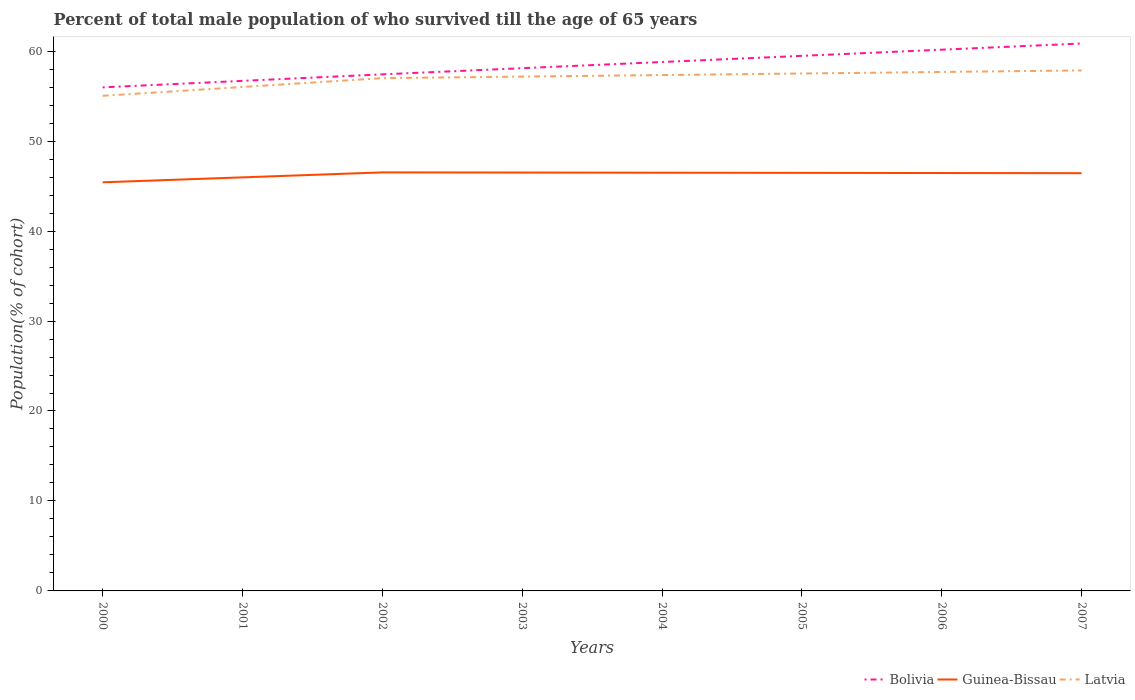How many different coloured lines are there?
Provide a short and direct response. 3. Across all years, what is the maximum percentage of total male population who survived till the age of 65 years in Bolivia?
Offer a very short reply. 55.97. In which year was the percentage of total male population who survived till the age of 65 years in Bolivia maximum?
Give a very brief answer. 2000. What is the total percentage of total male population who survived till the age of 65 years in Bolivia in the graph?
Offer a terse response. -3.5. What is the difference between the highest and the second highest percentage of total male population who survived till the age of 65 years in Bolivia?
Give a very brief answer. 4.87. What is the difference between the highest and the lowest percentage of total male population who survived till the age of 65 years in Bolivia?
Provide a short and direct response. 4. Is the percentage of total male population who survived till the age of 65 years in Latvia strictly greater than the percentage of total male population who survived till the age of 65 years in Bolivia over the years?
Keep it short and to the point. Yes. How many lines are there?
Provide a succinct answer. 3. Does the graph contain grids?
Give a very brief answer. No. What is the title of the graph?
Ensure brevity in your answer.  Percent of total male population of who survived till the age of 65 years. What is the label or title of the X-axis?
Make the answer very short. Years. What is the label or title of the Y-axis?
Make the answer very short. Population(% of cohort). What is the Population(% of cohort) in Bolivia in 2000?
Provide a short and direct response. 55.97. What is the Population(% of cohort) of Guinea-Bissau in 2000?
Give a very brief answer. 45.42. What is the Population(% of cohort) in Latvia in 2000?
Your answer should be compact. 55.03. What is the Population(% of cohort) in Bolivia in 2001?
Provide a succinct answer. 56.7. What is the Population(% of cohort) of Guinea-Bissau in 2001?
Your answer should be compact. 45.97. What is the Population(% of cohort) of Latvia in 2001?
Ensure brevity in your answer.  56.02. What is the Population(% of cohort) in Bolivia in 2002?
Provide a succinct answer. 57.42. What is the Population(% of cohort) of Guinea-Bissau in 2002?
Your response must be concise. 46.52. What is the Population(% of cohort) in Latvia in 2002?
Ensure brevity in your answer.  57. What is the Population(% of cohort) of Bolivia in 2003?
Keep it short and to the point. 58.1. What is the Population(% of cohort) of Guinea-Bissau in 2003?
Your answer should be very brief. 46.5. What is the Population(% of cohort) of Latvia in 2003?
Provide a succinct answer. 57.17. What is the Population(% of cohort) of Bolivia in 2004?
Keep it short and to the point. 58.79. What is the Population(% of cohort) of Guinea-Bissau in 2004?
Provide a succinct answer. 46.49. What is the Population(% of cohort) of Latvia in 2004?
Give a very brief answer. 57.34. What is the Population(% of cohort) of Bolivia in 2005?
Make the answer very short. 59.48. What is the Population(% of cohort) of Guinea-Bissau in 2005?
Give a very brief answer. 46.47. What is the Population(% of cohort) of Latvia in 2005?
Your response must be concise. 57.51. What is the Population(% of cohort) of Bolivia in 2006?
Your response must be concise. 60.16. What is the Population(% of cohort) in Guinea-Bissau in 2006?
Provide a short and direct response. 46.45. What is the Population(% of cohort) of Latvia in 2006?
Provide a short and direct response. 57.69. What is the Population(% of cohort) of Bolivia in 2007?
Give a very brief answer. 60.85. What is the Population(% of cohort) in Guinea-Bissau in 2007?
Ensure brevity in your answer.  46.43. What is the Population(% of cohort) of Latvia in 2007?
Make the answer very short. 57.86. Across all years, what is the maximum Population(% of cohort) of Bolivia?
Give a very brief answer. 60.85. Across all years, what is the maximum Population(% of cohort) in Guinea-Bissau?
Give a very brief answer. 46.52. Across all years, what is the maximum Population(% of cohort) of Latvia?
Offer a very short reply. 57.86. Across all years, what is the minimum Population(% of cohort) in Bolivia?
Offer a very short reply. 55.97. Across all years, what is the minimum Population(% of cohort) in Guinea-Bissau?
Ensure brevity in your answer.  45.42. Across all years, what is the minimum Population(% of cohort) in Latvia?
Offer a very short reply. 55.03. What is the total Population(% of cohort) in Bolivia in the graph?
Keep it short and to the point. 467.47. What is the total Population(% of cohort) of Guinea-Bissau in the graph?
Keep it short and to the point. 370.26. What is the total Population(% of cohort) of Latvia in the graph?
Keep it short and to the point. 455.62. What is the difference between the Population(% of cohort) of Bolivia in 2000 and that in 2001?
Offer a terse response. -0.72. What is the difference between the Population(% of cohort) of Guinea-Bissau in 2000 and that in 2001?
Your answer should be compact. -0.55. What is the difference between the Population(% of cohort) of Latvia in 2000 and that in 2001?
Give a very brief answer. -0.98. What is the difference between the Population(% of cohort) in Bolivia in 2000 and that in 2002?
Ensure brevity in your answer.  -1.45. What is the difference between the Population(% of cohort) in Guinea-Bissau in 2000 and that in 2002?
Your answer should be very brief. -1.1. What is the difference between the Population(% of cohort) of Latvia in 2000 and that in 2002?
Offer a very short reply. -1.96. What is the difference between the Population(% of cohort) in Bolivia in 2000 and that in 2003?
Offer a very short reply. -2.13. What is the difference between the Population(% of cohort) in Guinea-Bissau in 2000 and that in 2003?
Your response must be concise. -1.09. What is the difference between the Population(% of cohort) of Latvia in 2000 and that in 2003?
Ensure brevity in your answer.  -2.13. What is the difference between the Population(% of cohort) in Bolivia in 2000 and that in 2004?
Make the answer very short. -2.82. What is the difference between the Population(% of cohort) of Guinea-Bissau in 2000 and that in 2004?
Your answer should be very brief. -1.07. What is the difference between the Population(% of cohort) in Latvia in 2000 and that in 2004?
Offer a terse response. -2.31. What is the difference between the Population(% of cohort) in Bolivia in 2000 and that in 2005?
Offer a very short reply. -3.5. What is the difference between the Population(% of cohort) in Guinea-Bissau in 2000 and that in 2005?
Your response must be concise. -1.05. What is the difference between the Population(% of cohort) in Latvia in 2000 and that in 2005?
Offer a terse response. -2.48. What is the difference between the Population(% of cohort) of Bolivia in 2000 and that in 2006?
Offer a terse response. -4.19. What is the difference between the Population(% of cohort) in Guinea-Bissau in 2000 and that in 2006?
Your answer should be compact. -1.03. What is the difference between the Population(% of cohort) of Latvia in 2000 and that in 2006?
Provide a succinct answer. -2.65. What is the difference between the Population(% of cohort) of Bolivia in 2000 and that in 2007?
Your answer should be very brief. -4.87. What is the difference between the Population(% of cohort) in Guinea-Bissau in 2000 and that in 2007?
Your response must be concise. -1.02. What is the difference between the Population(% of cohort) of Latvia in 2000 and that in 2007?
Give a very brief answer. -2.82. What is the difference between the Population(% of cohort) of Bolivia in 2001 and that in 2002?
Keep it short and to the point. -0.72. What is the difference between the Population(% of cohort) of Guinea-Bissau in 2001 and that in 2002?
Provide a succinct answer. -0.55. What is the difference between the Population(% of cohort) in Latvia in 2001 and that in 2002?
Provide a succinct answer. -0.98. What is the difference between the Population(% of cohort) in Bolivia in 2001 and that in 2003?
Offer a terse response. -1.41. What is the difference between the Population(% of cohort) of Guinea-Bissau in 2001 and that in 2003?
Make the answer very short. -0.53. What is the difference between the Population(% of cohort) in Latvia in 2001 and that in 2003?
Make the answer very short. -1.15. What is the difference between the Population(% of cohort) in Bolivia in 2001 and that in 2004?
Your response must be concise. -2.09. What is the difference between the Population(% of cohort) of Guinea-Bissau in 2001 and that in 2004?
Offer a terse response. -0.52. What is the difference between the Population(% of cohort) of Latvia in 2001 and that in 2004?
Your answer should be compact. -1.33. What is the difference between the Population(% of cohort) in Bolivia in 2001 and that in 2005?
Ensure brevity in your answer.  -2.78. What is the difference between the Population(% of cohort) of Guinea-Bissau in 2001 and that in 2005?
Offer a terse response. -0.5. What is the difference between the Population(% of cohort) in Latvia in 2001 and that in 2005?
Your response must be concise. -1.5. What is the difference between the Population(% of cohort) of Bolivia in 2001 and that in 2006?
Your answer should be compact. -3.47. What is the difference between the Population(% of cohort) in Guinea-Bissau in 2001 and that in 2006?
Provide a short and direct response. -0.48. What is the difference between the Population(% of cohort) of Latvia in 2001 and that in 2006?
Offer a very short reply. -1.67. What is the difference between the Population(% of cohort) of Bolivia in 2001 and that in 2007?
Offer a terse response. -4.15. What is the difference between the Population(% of cohort) of Guinea-Bissau in 2001 and that in 2007?
Make the answer very short. -0.46. What is the difference between the Population(% of cohort) in Latvia in 2001 and that in 2007?
Provide a short and direct response. -1.84. What is the difference between the Population(% of cohort) in Bolivia in 2002 and that in 2003?
Offer a very short reply. -0.69. What is the difference between the Population(% of cohort) of Guinea-Bissau in 2002 and that in 2003?
Your response must be concise. 0.02. What is the difference between the Population(% of cohort) in Latvia in 2002 and that in 2003?
Offer a very short reply. -0.17. What is the difference between the Population(% of cohort) of Bolivia in 2002 and that in 2004?
Your response must be concise. -1.37. What is the difference between the Population(% of cohort) of Guinea-Bissau in 2002 and that in 2004?
Keep it short and to the point. 0.04. What is the difference between the Population(% of cohort) in Latvia in 2002 and that in 2004?
Provide a short and direct response. -0.34. What is the difference between the Population(% of cohort) of Bolivia in 2002 and that in 2005?
Offer a very short reply. -2.06. What is the difference between the Population(% of cohort) in Guinea-Bissau in 2002 and that in 2005?
Keep it short and to the point. 0.05. What is the difference between the Population(% of cohort) of Latvia in 2002 and that in 2005?
Keep it short and to the point. -0.52. What is the difference between the Population(% of cohort) in Bolivia in 2002 and that in 2006?
Keep it short and to the point. -2.74. What is the difference between the Population(% of cohort) in Guinea-Bissau in 2002 and that in 2006?
Your response must be concise. 0.07. What is the difference between the Population(% of cohort) of Latvia in 2002 and that in 2006?
Ensure brevity in your answer.  -0.69. What is the difference between the Population(% of cohort) in Bolivia in 2002 and that in 2007?
Give a very brief answer. -3.43. What is the difference between the Population(% of cohort) in Guinea-Bissau in 2002 and that in 2007?
Keep it short and to the point. 0.09. What is the difference between the Population(% of cohort) of Latvia in 2002 and that in 2007?
Your answer should be compact. -0.86. What is the difference between the Population(% of cohort) in Bolivia in 2003 and that in 2004?
Give a very brief answer. -0.69. What is the difference between the Population(% of cohort) in Guinea-Bissau in 2003 and that in 2004?
Keep it short and to the point. 0.02. What is the difference between the Population(% of cohort) of Latvia in 2003 and that in 2004?
Your response must be concise. -0.17. What is the difference between the Population(% of cohort) of Bolivia in 2003 and that in 2005?
Offer a very short reply. -1.37. What is the difference between the Population(% of cohort) in Guinea-Bissau in 2003 and that in 2005?
Give a very brief answer. 0.04. What is the difference between the Population(% of cohort) in Latvia in 2003 and that in 2005?
Provide a succinct answer. -0.34. What is the difference between the Population(% of cohort) in Bolivia in 2003 and that in 2006?
Give a very brief answer. -2.06. What is the difference between the Population(% of cohort) in Guinea-Bissau in 2003 and that in 2006?
Keep it short and to the point. 0.05. What is the difference between the Population(% of cohort) of Latvia in 2003 and that in 2006?
Your answer should be very brief. -0.52. What is the difference between the Population(% of cohort) of Bolivia in 2003 and that in 2007?
Provide a short and direct response. -2.74. What is the difference between the Population(% of cohort) of Guinea-Bissau in 2003 and that in 2007?
Provide a succinct answer. 0.07. What is the difference between the Population(% of cohort) in Latvia in 2003 and that in 2007?
Your answer should be very brief. -0.69. What is the difference between the Population(% of cohort) in Bolivia in 2004 and that in 2005?
Your response must be concise. -0.69. What is the difference between the Population(% of cohort) of Guinea-Bissau in 2004 and that in 2005?
Give a very brief answer. 0.02. What is the difference between the Population(% of cohort) of Latvia in 2004 and that in 2005?
Your answer should be very brief. -0.17. What is the difference between the Population(% of cohort) in Bolivia in 2004 and that in 2006?
Make the answer very short. -1.37. What is the difference between the Population(% of cohort) in Guinea-Bissau in 2004 and that in 2006?
Offer a terse response. 0.04. What is the difference between the Population(% of cohort) in Latvia in 2004 and that in 2006?
Ensure brevity in your answer.  -0.34. What is the difference between the Population(% of cohort) of Bolivia in 2004 and that in 2007?
Your answer should be very brief. -2.06. What is the difference between the Population(% of cohort) of Guinea-Bissau in 2004 and that in 2007?
Your answer should be compact. 0.05. What is the difference between the Population(% of cohort) of Latvia in 2004 and that in 2007?
Ensure brevity in your answer.  -0.52. What is the difference between the Population(% of cohort) of Bolivia in 2005 and that in 2006?
Provide a short and direct response. -0.69. What is the difference between the Population(% of cohort) in Guinea-Bissau in 2005 and that in 2006?
Keep it short and to the point. 0.02. What is the difference between the Population(% of cohort) in Latvia in 2005 and that in 2006?
Your response must be concise. -0.17. What is the difference between the Population(% of cohort) of Bolivia in 2005 and that in 2007?
Your answer should be compact. -1.37. What is the difference between the Population(% of cohort) of Guinea-Bissau in 2005 and that in 2007?
Ensure brevity in your answer.  0.04. What is the difference between the Population(% of cohort) in Latvia in 2005 and that in 2007?
Your answer should be very brief. -0.34. What is the difference between the Population(% of cohort) in Bolivia in 2006 and that in 2007?
Give a very brief answer. -0.69. What is the difference between the Population(% of cohort) in Guinea-Bissau in 2006 and that in 2007?
Your answer should be compact. 0.02. What is the difference between the Population(% of cohort) of Latvia in 2006 and that in 2007?
Keep it short and to the point. -0.17. What is the difference between the Population(% of cohort) in Bolivia in 2000 and the Population(% of cohort) in Guinea-Bissau in 2001?
Keep it short and to the point. 10. What is the difference between the Population(% of cohort) of Bolivia in 2000 and the Population(% of cohort) of Latvia in 2001?
Your answer should be very brief. -0.04. What is the difference between the Population(% of cohort) of Guinea-Bissau in 2000 and the Population(% of cohort) of Latvia in 2001?
Your response must be concise. -10.6. What is the difference between the Population(% of cohort) in Bolivia in 2000 and the Population(% of cohort) in Guinea-Bissau in 2002?
Your answer should be compact. 9.45. What is the difference between the Population(% of cohort) of Bolivia in 2000 and the Population(% of cohort) of Latvia in 2002?
Ensure brevity in your answer.  -1.02. What is the difference between the Population(% of cohort) of Guinea-Bissau in 2000 and the Population(% of cohort) of Latvia in 2002?
Your answer should be very brief. -11.58. What is the difference between the Population(% of cohort) of Bolivia in 2000 and the Population(% of cohort) of Guinea-Bissau in 2003?
Provide a succinct answer. 9.47. What is the difference between the Population(% of cohort) of Bolivia in 2000 and the Population(% of cohort) of Latvia in 2003?
Provide a short and direct response. -1.2. What is the difference between the Population(% of cohort) of Guinea-Bissau in 2000 and the Population(% of cohort) of Latvia in 2003?
Provide a short and direct response. -11.75. What is the difference between the Population(% of cohort) of Bolivia in 2000 and the Population(% of cohort) of Guinea-Bissau in 2004?
Ensure brevity in your answer.  9.49. What is the difference between the Population(% of cohort) in Bolivia in 2000 and the Population(% of cohort) in Latvia in 2004?
Your answer should be very brief. -1.37. What is the difference between the Population(% of cohort) in Guinea-Bissau in 2000 and the Population(% of cohort) in Latvia in 2004?
Give a very brief answer. -11.92. What is the difference between the Population(% of cohort) of Bolivia in 2000 and the Population(% of cohort) of Guinea-Bissau in 2005?
Provide a short and direct response. 9.5. What is the difference between the Population(% of cohort) in Bolivia in 2000 and the Population(% of cohort) in Latvia in 2005?
Make the answer very short. -1.54. What is the difference between the Population(% of cohort) in Guinea-Bissau in 2000 and the Population(% of cohort) in Latvia in 2005?
Keep it short and to the point. -12.1. What is the difference between the Population(% of cohort) of Bolivia in 2000 and the Population(% of cohort) of Guinea-Bissau in 2006?
Your answer should be very brief. 9.52. What is the difference between the Population(% of cohort) in Bolivia in 2000 and the Population(% of cohort) in Latvia in 2006?
Your answer should be very brief. -1.71. What is the difference between the Population(% of cohort) in Guinea-Bissau in 2000 and the Population(% of cohort) in Latvia in 2006?
Provide a succinct answer. -12.27. What is the difference between the Population(% of cohort) of Bolivia in 2000 and the Population(% of cohort) of Guinea-Bissau in 2007?
Provide a succinct answer. 9.54. What is the difference between the Population(% of cohort) of Bolivia in 2000 and the Population(% of cohort) of Latvia in 2007?
Your answer should be very brief. -1.88. What is the difference between the Population(% of cohort) of Guinea-Bissau in 2000 and the Population(% of cohort) of Latvia in 2007?
Your answer should be compact. -12.44. What is the difference between the Population(% of cohort) in Bolivia in 2001 and the Population(% of cohort) in Guinea-Bissau in 2002?
Make the answer very short. 10.17. What is the difference between the Population(% of cohort) in Bolivia in 2001 and the Population(% of cohort) in Latvia in 2002?
Ensure brevity in your answer.  -0.3. What is the difference between the Population(% of cohort) in Guinea-Bissau in 2001 and the Population(% of cohort) in Latvia in 2002?
Provide a succinct answer. -11.03. What is the difference between the Population(% of cohort) of Bolivia in 2001 and the Population(% of cohort) of Guinea-Bissau in 2003?
Your response must be concise. 10.19. What is the difference between the Population(% of cohort) of Bolivia in 2001 and the Population(% of cohort) of Latvia in 2003?
Your response must be concise. -0.47. What is the difference between the Population(% of cohort) in Guinea-Bissau in 2001 and the Population(% of cohort) in Latvia in 2003?
Your response must be concise. -11.2. What is the difference between the Population(% of cohort) of Bolivia in 2001 and the Population(% of cohort) of Guinea-Bissau in 2004?
Provide a short and direct response. 10.21. What is the difference between the Population(% of cohort) of Bolivia in 2001 and the Population(% of cohort) of Latvia in 2004?
Provide a succinct answer. -0.65. What is the difference between the Population(% of cohort) in Guinea-Bissau in 2001 and the Population(% of cohort) in Latvia in 2004?
Your response must be concise. -11.37. What is the difference between the Population(% of cohort) in Bolivia in 2001 and the Population(% of cohort) in Guinea-Bissau in 2005?
Give a very brief answer. 10.23. What is the difference between the Population(% of cohort) of Bolivia in 2001 and the Population(% of cohort) of Latvia in 2005?
Offer a very short reply. -0.82. What is the difference between the Population(% of cohort) in Guinea-Bissau in 2001 and the Population(% of cohort) in Latvia in 2005?
Your response must be concise. -11.54. What is the difference between the Population(% of cohort) of Bolivia in 2001 and the Population(% of cohort) of Guinea-Bissau in 2006?
Keep it short and to the point. 10.24. What is the difference between the Population(% of cohort) of Bolivia in 2001 and the Population(% of cohort) of Latvia in 2006?
Offer a terse response. -0.99. What is the difference between the Population(% of cohort) in Guinea-Bissau in 2001 and the Population(% of cohort) in Latvia in 2006?
Provide a succinct answer. -11.72. What is the difference between the Population(% of cohort) in Bolivia in 2001 and the Population(% of cohort) in Guinea-Bissau in 2007?
Offer a terse response. 10.26. What is the difference between the Population(% of cohort) of Bolivia in 2001 and the Population(% of cohort) of Latvia in 2007?
Your answer should be very brief. -1.16. What is the difference between the Population(% of cohort) of Guinea-Bissau in 2001 and the Population(% of cohort) of Latvia in 2007?
Give a very brief answer. -11.89. What is the difference between the Population(% of cohort) of Bolivia in 2002 and the Population(% of cohort) of Guinea-Bissau in 2003?
Ensure brevity in your answer.  10.91. What is the difference between the Population(% of cohort) of Bolivia in 2002 and the Population(% of cohort) of Latvia in 2003?
Give a very brief answer. 0.25. What is the difference between the Population(% of cohort) in Guinea-Bissau in 2002 and the Population(% of cohort) in Latvia in 2003?
Offer a terse response. -10.65. What is the difference between the Population(% of cohort) in Bolivia in 2002 and the Population(% of cohort) in Guinea-Bissau in 2004?
Provide a succinct answer. 10.93. What is the difference between the Population(% of cohort) in Bolivia in 2002 and the Population(% of cohort) in Latvia in 2004?
Provide a short and direct response. 0.08. What is the difference between the Population(% of cohort) of Guinea-Bissau in 2002 and the Population(% of cohort) of Latvia in 2004?
Keep it short and to the point. -10.82. What is the difference between the Population(% of cohort) in Bolivia in 2002 and the Population(% of cohort) in Guinea-Bissau in 2005?
Offer a very short reply. 10.95. What is the difference between the Population(% of cohort) in Bolivia in 2002 and the Population(% of cohort) in Latvia in 2005?
Keep it short and to the point. -0.09. What is the difference between the Population(% of cohort) in Guinea-Bissau in 2002 and the Population(% of cohort) in Latvia in 2005?
Offer a very short reply. -10.99. What is the difference between the Population(% of cohort) of Bolivia in 2002 and the Population(% of cohort) of Guinea-Bissau in 2006?
Your response must be concise. 10.97. What is the difference between the Population(% of cohort) in Bolivia in 2002 and the Population(% of cohort) in Latvia in 2006?
Provide a short and direct response. -0.27. What is the difference between the Population(% of cohort) in Guinea-Bissau in 2002 and the Population(% of cohort) in Latvia in 2006?
Your answer should be very brief. -11.16. What is the difference between the Population(% of cohort) of Bolivia in 2002 and the Population(% of cohort) of Guinea-Bissau in 2007?
Your answer should be very brief. 10.99. What is the difference between the Population(% of cohort) in Bolivia in 2002 and the Population(% of cohort) in Latvia in 2007?
Provide a succinct answer. -0.44. What is the difference between the Population(% of cohort) in Guinea-Bissau in 2002 and the Population(% of cohort) in Latvia in 2007?
Give a very brief answer. -11.34. What is the difference between the Population(% of cohort) of Bolivia in 2003 and the Population(% of cohort) of Guinea-Bissau in 2004?
Provide a short and direct response. 11.62. What is the difference between the Population(% of cohort) in Bolivia in 2003 and the Population(% of cohort) in Latvia in 2004?
Make the answer very short. 0.76. What is the difference between the Population(% of cohort) in Guinea-Bissau in 2003 and the Population(% of cohort) in Latvia in 2004?
Your answer should be very brief. -10.84. What is the difference between the Population(% of cohort) in Bolivia in 2003 and the Population(% of cohort) in Guinea-Bissau in 2005?
Provide a succinct answer. 11.64. What is the difference between the Population(% of cohort) in Bolivia in 2003 and the Population(% of cohort) in Latvia in 2005?
Your answer should be very brief. 0.59. What is the difference between the Population(% of cohort) of Guinea-Bissau in 2003 and the Population(% of cohort) of Latvia in 2005?
Provide a succinct answer. -11.01. What is the difference between the Population(% of cohort) in Bolivia in 2003 and the Population(% of cohort) in Guinea-Bissau in 2006?
Your answer should be very brief. 11.65. What is the difference between the Population(% of cohort) in Bolivia in 2003 and the Population(% of cohort) in Latvia in 2006?
Offer a terse response. 0.42. What is the difference between the Population(% of cohort) in Guinea-Bissau in 2003 and the Population(% of cohort) in Latvia in 2006?
Your answer should be compact. -11.18. What is the difference between the Population(% of cohort) of Bolivia in 2003 and the Population(% of cohort) of Guinea-Bissau in 2007?
Provide a short and direct response. 11.67. What is the difference between the Population(% of cohort) of Bolivia in 2003 and the Population(% of cohort) of Latvia in 2007?
Make the answer very short. 0.25. What is the difference between the Population(% of cohort) in Guinea-Bissau in 2003 and the Population(% of cohort) in Latvia in 2007?
Ensure brevity in your answer.  -11.35. What is the difference between the Population(% of cohort) of Bolivia in 2004 and the Population(% of cohort) of Guinea-Bissau in 2005?
Your response must be concise. 12.32. What is the difference between the Population(% of cohort) of Bolivia in 2004 and the Population(% of cohort) of Latvia in 2005?
Ensure brevity in your answer.  1.28. What is the difference between the Population(% of cohort) of Guinea-Bissau in 2004 and the Population(% of cohort) of Latvia in 2005?
Keep it short and to the point. -11.03. What is the difference between the Population(% of cohort) in Bolivia in 2004 and the Population(% of cohort) in Guinea-Bissau in 2006?
Make the answer very short. 12.34. What is the difference between the Population(% of cohort) of Bolivia in 2004 and the Population(% of cohort) of Latvia in 2006?
Ensure brevity in your answer.  1.1. What is the difference between the Population(% of cohort) of Guinea-Bissau in 2004 and the Population(% of cohort) of Latvia in 2006?
Your response must be concise. -11.2. What is the difference between the Population(% of cohort) of Bolivia in 2004 and the Population(% of cohort) of Guinea-Bissau in 2007?
Offer a terse response. 12.36. What is the difference between the Population(% of cohort) of Bolivia in 2004 and the Population(% of cohort) of Latvia in 2007?
Offer a terse response. 0.93. What is the difference between the Population(% of cohort) of Guinea-Bissau in 2004 and the Population(% of cohort) of Latvia in 2007?
Your answer should be very brief. -11.37. What is the difference between the Population(% of cohort) in Bolivia in 2005 and the Population(% of cohort) in Guinea-Bissau in 2006?
Make the answer very short. 13.02. What is the difference between the Population(% of cohort) of Bolivia in 2005 and the Population(% of cohort) of Latvia in 2006?
Provide a succinct answer. 1.79. What is the difference between the Population(% of cohort) in Guinea-Bissau in 2005 and the Population(% of cohort) in Latvia in 2006?
Your answer should be compact. -11.22. What is the difference between the Population(% of cohort) of Bolivia in 2005 and the Population(% of cohort) of Guinea-Bissau in 2007?
Keep it short and to the point. 13.04. What is the difference between the Population(% of cohort) in Bolivia in 2005 and the Population(% of cohort) in Latvia in 2007?
Offer a terse response. 1.62. What is the difference between the Population(% of cohort) in Guinea-Bissau in 2005 and the Population(% of cohort) in Latvia in 2007?
Your answer should be compact. -11.39. What is the difference between the Population(% of cohort) in Bolivia in 2006 and the Population(% of cohort) in Guinea-Bissau in 2007?
Your answer should be compact. 13.73. What is the difference between the Population(% of cohort) of Bolivia in 2006 and the Population(% of cohort) of Latvia in 2007?
Keep it short and to the point. 2.3. What is the difference between the Population(% of cohort) in Guinea-Bissau in 2006 and the Population(% of cohort) in Latvia in 2007?
Offer a terse response. -11.41. What is the average Population(% of cohort) of Bolivia per year?
Provide a short and direct response. 58.43. What is the average Population(% of cohort) in Guinea-Bissau per year?
Provide a short and direct response. 46.28. What is the average Population(% of cohort) of Latvia per year?
Provide a short and direct response. 56.95. In the year 2000, what is the difference between the Population(% of cohort) of Bolivia and Population(% of cohort) of Guinea-Bissau?
Keep it short and to the point. 10.56. In the year 2000, what is the difference between the Population(% of cohort) of Bolivia and Population(% of cohort) of Latvia?
Your answer should be very brief. 0.94. In the year 2000, what is the difference between the Population(% of cohort) in Guinea-Bissau and Population(% of cohort) in Latvia?
Offer a terse response. -9.62. In the year 2001, what is the difference between the Population(% of cohort) of Bolivia and Population(% of cohort) of Guinea-Bissau?
Give a very brief answer. 10.73. In the year 2001, what is the difference between the Population(% of cohort) in Bolivia and Population(% of cohort) in Latvia?
Keep it short and to the point. 0.68. In the year 2001, what is the difference between the Population(% of cohort) in Guinea-Bissau and Population(% of cohort) in Latvia?
Give a very brief answer. -10.05. In the year 2002, what is the difference between the Population(% of cohort) in Bolivia and Population(% of cohort) in Guinea-Bissau?
Provide a short and direct response. 10.9. In the year 2002, what is the difference between the Population(% of cohort) of Bolivia and Population(% of cohort) of Latvia?
Keep it short and to the point. 0.42. In the year 2002, what is the difference between the Population(% of cohort) of Guinea-Bissau and Population(% of cohort) of Latvia?
Your response must be concise. -10.48. In the year 2003, what is the difference between the Population(% of cohort) in Bolivia and Population(% of cohort) in Guinea-Bissau?
Ensure brevity in your answer.  11.6. In the year 2003, what is the difference between the Population(% of cohort) of Bolivia and Population(% of cohort) of Latvia?
Provide a succinct answer. 0.94. In the year 2003, what is the difference between the Population(% of cohort) of Guinea-Bissau and Population(% of cohort) of Latvia?
Give a very brief answer. -10.67. In the year 2004, what is the difference between the Population(% of cohort) of Bolivia and Population(% of cohort) of Guinea-Bissau?
Your answer should be very brief. 12.3. In the year 2004, what is the difference between the Population(% of cohort) of Bolivia and Population(% of cohort) of Latvia?
Your response must be concise. 1.45. In the year 2004, what is the difference between the Population(% of cohort) in Guinea-Bissau and Population(% of cohort) in Latvia?
Keep it short and to the point. -10.85. In the year 2005, what is the difference between the Population(% of cohort) of Bolivia and Population(% of cohort) of Guinea-Bissau?
Ensure brevity in your answer.  13.01. In the year 2005, what is the difference between the Population(% of cohort) of Bolivia and Population(% of cohort) of Latvia?
Your answer should be compact. 1.96. In the year 2005, what is the difference between the Population(% of cohort) of Guinea-Bissau and Population(% of cohort) of Latvia?
Your response must be concise. -11.04. In the year 2006, what is the difference between the Population(% of cohort) of Bolivia and Population(% of cohort) of Guinea-Bissau?
Make the answer very short. 13.71. In the year 2006, what is the difference between the Population(% of cohort) in Bolivia and Population(% of cohort) in Latvia?
Give a very brief answer. 2.48. In the year 2006, what is the difference between the Population(% of cohort) of Guinea-Bissau and Population(% of cohort) of Latvia?
Your answer should be compact. -11.23. In the year 2007, what is the difference between the Population(% of cohort) of Bolivia and Population(% of cohort) of Guinea-Bissau?
Keep it short and to the point. 14.41. In the year 2007, what is the difference between the Population(% of cohort) in Bolivia and Population(% of cohort) in Latvia?
Your answer should be very brief. 2.99. In the year 2007, what is the difference between the Population(% of cohort) in Guinea-Bissau and Population(% of cohort) in Latvia?
Your answer should be very brief. -11.42. What is the ratio of the Population(% of cohort) in Bolivia in 2000 to that in 2001?
Ensure brevity in your answer.  0.99. What is the ratio of the Population(% of cohort) of Guinea-Bissau in 2000 to that in 2001?
Give a very brief answer. 0.99. What is the ratio of the Population(% of cohort) in Latvia in 2000 to that in 2001?
Provide a succinct answer. 0.98. What is the ratio of the Population(% of cohort) of Bolivia in 2000 to that in 2002?
Offer a terse response. 0.97. What is the ratio of the Population(% of cohort) of Guinea-Bissau in 2000 to that in 2002?
Provide a succinct answer. 0.98. What is the ratio of the Population(% of cohort) of Latvia in 2000 to that in 2002?
Provide a succinct answer. 0.97. What is the ratio of the Population(% of cohort) of Bolivia in 2000 to that in 2003?
Provide a succinct answer. 0.96. What is the ratio of the Population(% of cohort) in Guinea-Bissau in 2000 to that in 2003?
Your response must be concise. 0.98. What is the ratio of the Population(% of cohort) of Latvia in 2000 to that in 2003?
Keep it short and to the point. 0.96. What is the ratio of the Population(% of cohort) of Bolivia in 2000 to that in 2004?
Provide a short and direct response. 0.95. What is the ratio of the Population(% of cohort) of Guinea-Bissau in 2000 to that in 2004?
Provide a succinct answer. 0.98. What is the ratio of the Population(% of cohort) in Latvia in 2000 to that in 2004?
Your response must be concise. 0.96. What is the ratio of the Population(% of cohort) of Bolivia in 2000 to that in 2005?
Provide a succinct answer. 0.94. What is the ratio of the Population(% of cohort) in Guinea-Bissau in 2000 to that in 2005?
Offer a terse response. 0.98. What is the ratio of the Population(% of cohort) of Latvia in 2000 to that in 2005?
Give a very brief answer. 0.96. What is the ratio of the Population(% of cohort) of Bolivia in 2000 to that in 2006?
Provide a short and direct response. 0.93. What is the ratio of the Population(% of cohort) of Guinea-Bissau in 2000 to that in 2006?
Give a very brief answer. 0.98. What is the ratio of the Population(% of cohort) of Latvia in 2000 to that in 2006?
Provide a short and direct response. 0.95. What is the ratio of the Population(% of cohort) of Bolivia in 2000 to that in 2007?
Provide a succinct answer. 0.92. What is the ratio of the Population(% of cohort) in Guinea-Bissau in 2000 to that in 2007?
Ensure brevity in your answer.  0.98. What is the ratio of the Population(% of cohort) of Latvia in 2000 to that in 2007?
Offer a terse response. 0.95. What is the ratio of the Population(% of cohort) in Bolivia in 2001 to that in 2002?
Provide a short and direct response. 0.99. What is the ratio of the Population(% of cohort) of Guinea-Bissau in 2001 to that in 2002?
Offer a very short reply. 0.99. What is the ratio of the Population(% of cohort) of Latvia in 2001 to that in 2002?
Give a very brief answer. 0.98. What is the ratio of the Population(% of cohort) in Bolivia in 2001 to that in 2003?
Your answer should be very brief. 0.98. What is the ratio of the Population(% of cohort) in Latvia in 2001 to that in 2003?
Ensure brevity in your answer.  0.98. What is the ratio of the Population(% of cohort) of Bolivia in 2001 to that in 2004?
Give a very brief answer. 0.96. What is the ratio of the Population(% of cohort) in Guinea-Bissau in 2001 to that in 2004?
Give a very brief answer. 0.99. What is the ratio of the Population(% of cohort) of Latvia in 2001 to that in 2004?
Provide a succinct answer. 0.98. What is the ratio of the Population(% of cohort) of Bolivia in 2001 to that in 2005?
Your answer should be very brief. 0.95. What is the ratio of the Population(% of cohort) of Guinea-Bissau in 2001 to that in 2005?
Offer a very short reply. 0.99. What is the ratio of the Population(% of cohort) of Latvia in 2001 to that in 2005?
Your answer should be very brief. 0.97. What is the ratio of the Population(% of cohort) of Bolivia in 2001 to that in 2006?
Your answer should be compact. 0.94. What is the ratio of the Population(% of cohort) in Guinea-Bissau in 2001 to that in 2006?
Provide a short and direct response. 0.99. What is the ratio of the Population(% of cohort) in Latvia in 2001 to that in 2006?
Make the answer very short. 0.97. What is the ratio of the Population(% of cohort) in Bolivia in 2001 to that in 2007?
Your answer should be compact. 0.93. What is the ratio of the Population(% of cohort) of Latvia in 2001 to that in 2007?
Your answer should be very brief. 0.97. What is the ratio of the Population(% of cohort) of Bolivia in 2002 to that in 2004?
Make the answer very short. 0.98. What is the ratio of the Population(% of cohort) in Bolivia in 2002 to that in 2005?
Provide a short and direct response. 0.97. What is the ratio of the Population(% of cohort) of Latvia in 2002 to that in 2005?
Your answer should be very brief. 0.99. What is the ratio of the Population(% of cohort) in Bolivia in 2002 to that in 2006?
Your response must be concise. 0.95. What is the ratio of the Population(% of cohort) of Latvia in 2002 to that in 2006?
Provide a succinct answer. 0.99. What is the ratio of the Population(% of cohort) of Bolivia in 2002 to that in 2007?
Offer a terse response. 0.94. What is the ratio of the Population(% of cohort) of Guinea-Bissau in 2002 to that in 2007?
Give a very brief answer. 1. What is the ratio of the Population(% of cohort) of Latvia in 2002 to that in 2007?
Make the answer very short. 0.99. What is the ratio of the Population(% of cohort) of Bolivia in 2003 to that in 2004?
Give a very brief answer. 0.99. What is the ratio of the Population(% of cohort) of Bolivia in 2003 to that in 2005?
Your response must be concise. 0.98. What is the ratio of the Population(% of cohort) in Bolivia in 2003 to that in 2006?
Give a very brief answer. 0.97. What is the ratio of the Population(% of cohort) of Latvia in 2003 to that in 2006?
Offer a terse response. 0.99. What is the ratio of the Population(% of cohort) in Bolivia in 2003 to that in 2007?
Your answer should be compact. 0.95. What is the ratio of the Population(% of cohort) of Latvia in 2003 to that in 2007?
Your answer should be compact. 0.99. What is the ratio of the Population(% of cohort) in Latvia in 2004 to that in 2005?
Keep it short and to the point. 1. What is the ratio of the Population(% of cohort) of Bolivia in 2004 to that in 2006?
Your answer should be very brief. 0.98. What is the ratio of the Population(% of cohort) of Guinea-Bissau in 2004 to that in 2006?
Provide a short and direct response. 1. What is the ratio of the Population(% of cohort) of Latvia in 2004 to that in 2006?
Give a very brief answer. 0.99. What is the ratio of the Population(% of cohort) in Bolivia in 2004 to that in 2007?
Provide a succinct answer. 0.97. What is the ratio of the Population(% of cohort) in Guinea-Bissau in 2005 to that in 2006?
Offer a terse response. 1. What is the ratio of the Population(% of cohort) in Bolivia in 2005 to that in 2007?
Your answer should be compact. 0.98. What is the ratio of the Population(% of cohort) of Latvia in 2005 to that in 2007?
Your response must be concise. 0.99. What is the ratio of the Population(% of cohort) in Bolivia in 2006 to that in 2007?
Provide a succinct answer. 0.99. What is the ratio of the Population(% of cohort) in Latvia in 2006 to that in 2007?
Your answer should be very brief. 1. What is the difference between the highest and the second highest Population(% of cohort) of Bolivia?
Your answer should be compact. 0.69. What is the difference between the highest and the second highest Population(% of cohort) in Guinea-Bissau?
Keep it short and to the point. 0.02. What is the difference between the highest and the second highest Population(% of cohort) of Latvia?
Keep it short and to the point. 0.17. What is the difference between the highest and the lowest Population(% of cohort) in Bolivia?
Provide a succinct answer. 4.87. What is the difference between the highest and the lowest Population(% of cohort) of Guinea-Bissau?
Your answer should be very brief. 1.1. What is the difference between the highest and the lowest Population(% of cohort) of Latvia?
Provide a succinct answer. 2.82. 